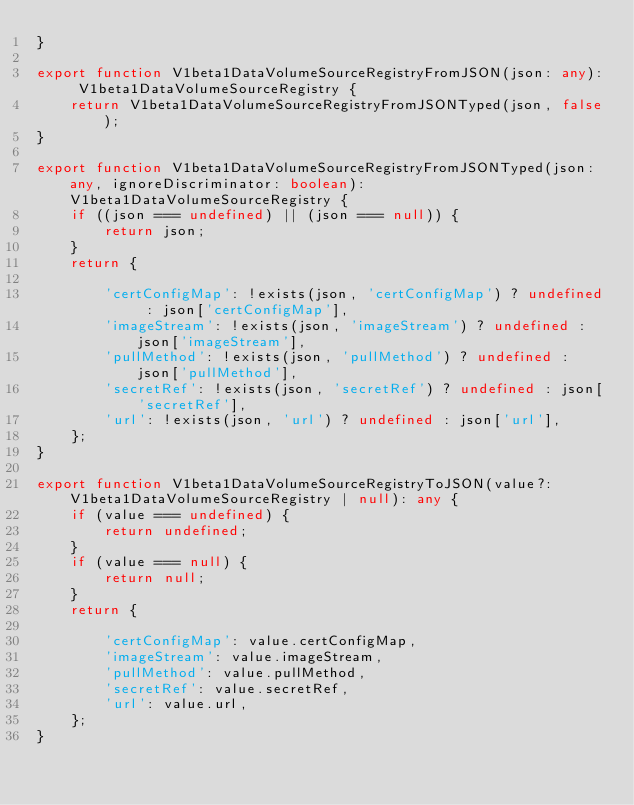Convert code to text. <code><loc_0><loc_0><loc_500><loc_500><_TypeScript_>}

export function V1beta1DataVolumeSourceRegistryFromJSON(json: any): V1beta1DataVolumeSourceRegistry {
    return V1beta1DataVolumeSourceRegistryFromJSONTyped(json, false);
}

export function V1beta1DataVolumeSourceRegistryFromJSONTyped(json: any, ignoreDiscriminator: boolean): V1beta1DataVolumeSourceRegistry {
    if ((json === undefined) || (json === null)) {
        return json;
    }
    return {
        
        'certConfigMap': !exists(json, 'certConfigMap') ? undefined : json['certConfigMap'],
        'imageStream': !exists(json, 'imageStream') ? undefined : json['imageStream'],
        'pullMethod': !exists(json, 'pullMethod') ? undefined : json['pullMethod'],
        'secretRef': !exists(json, 'secretRef') ? undefined : json['secretRef'],
        'url': !exists(json, 'url') ? undefined : json['url'],
    };
}

export function V1beta1DataVolumeSourceRegistryToJSON(value?: V1beta1DataVolumeSourceRegistry | null): any {
    if (value === undefined) {
        return undefined;
    }
    if (value === null) {
        return null;
    }
    return {
        
        'certConfigMap': value.certConfigMap,
        'imageStream': value.imageStream,
        'pullMethod': value.pullMethod,
        'secretRef': value.secretRef,
        'url': value.url,
    };
}

</code> 